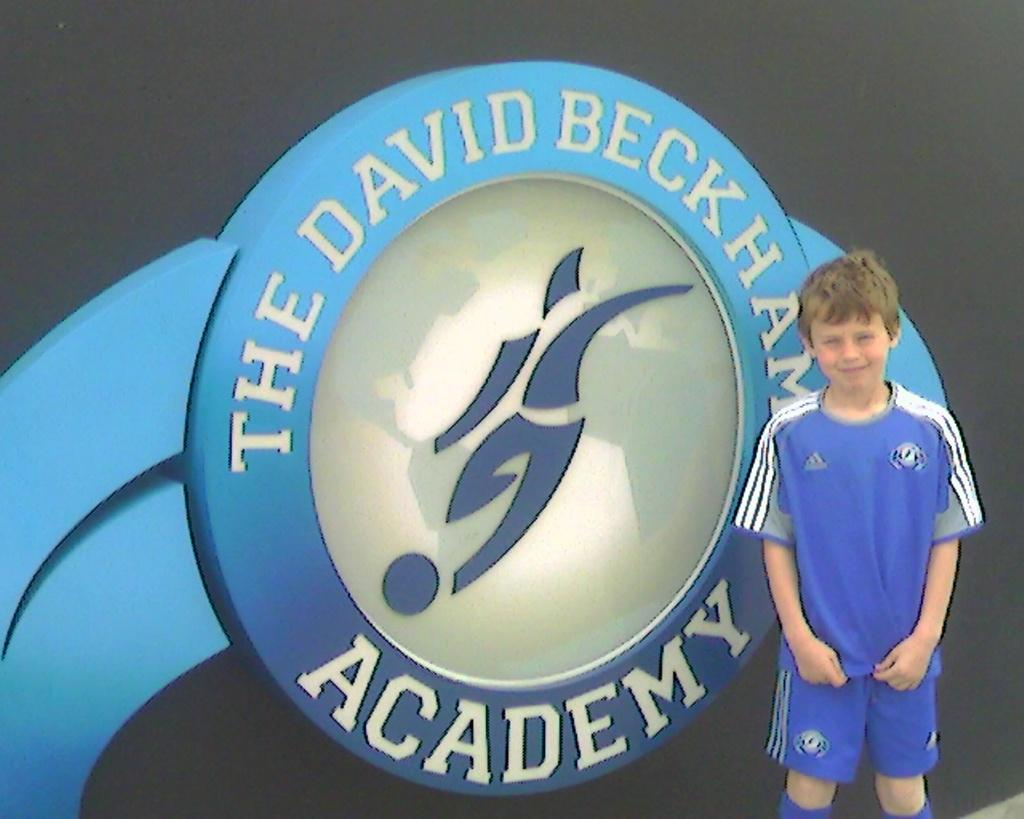<image>
Give a short and clear explanation of the subsequent image. A young player poses in front of the David Beckham Academy logo. 